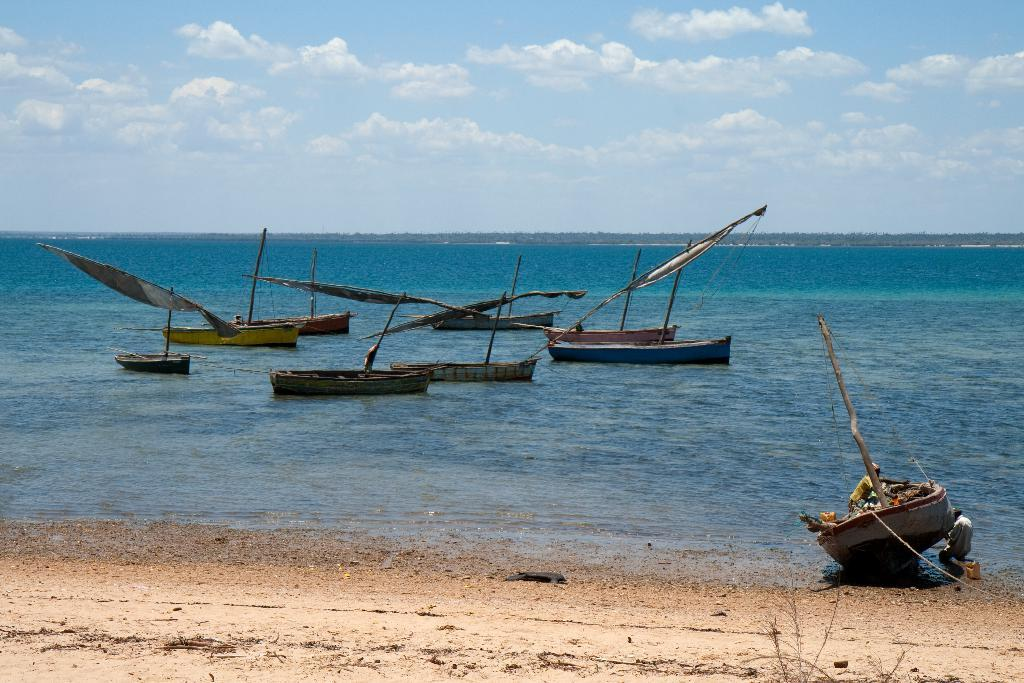What is the condition of the sky in the image? The sky is cloudy in the image. What can be seen in the water in the image? There is no specific detail about the water in the image, but it is visible. What is located above the water in the image? There are boats above the water in the image. What type of berry can be heard singing in the image? There is no berry or singing voice present in the image. 